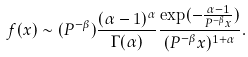Convert formula to latex. <formula><loc_0><loc_0><loc_500><loc_500>f ( x ) \sim ( P ^ { - \beta } ) \frac { ( \alpha - 1 ) ^ { \alpha } } { \Gamma ( \alpha ) } \frac { \exp ( - \frac { \alpha - 1 } { P ^ { - \beta } x } ) } { ( P ^ { - \beta } x ) ^ { 1 + \alpha } } .</formula> 